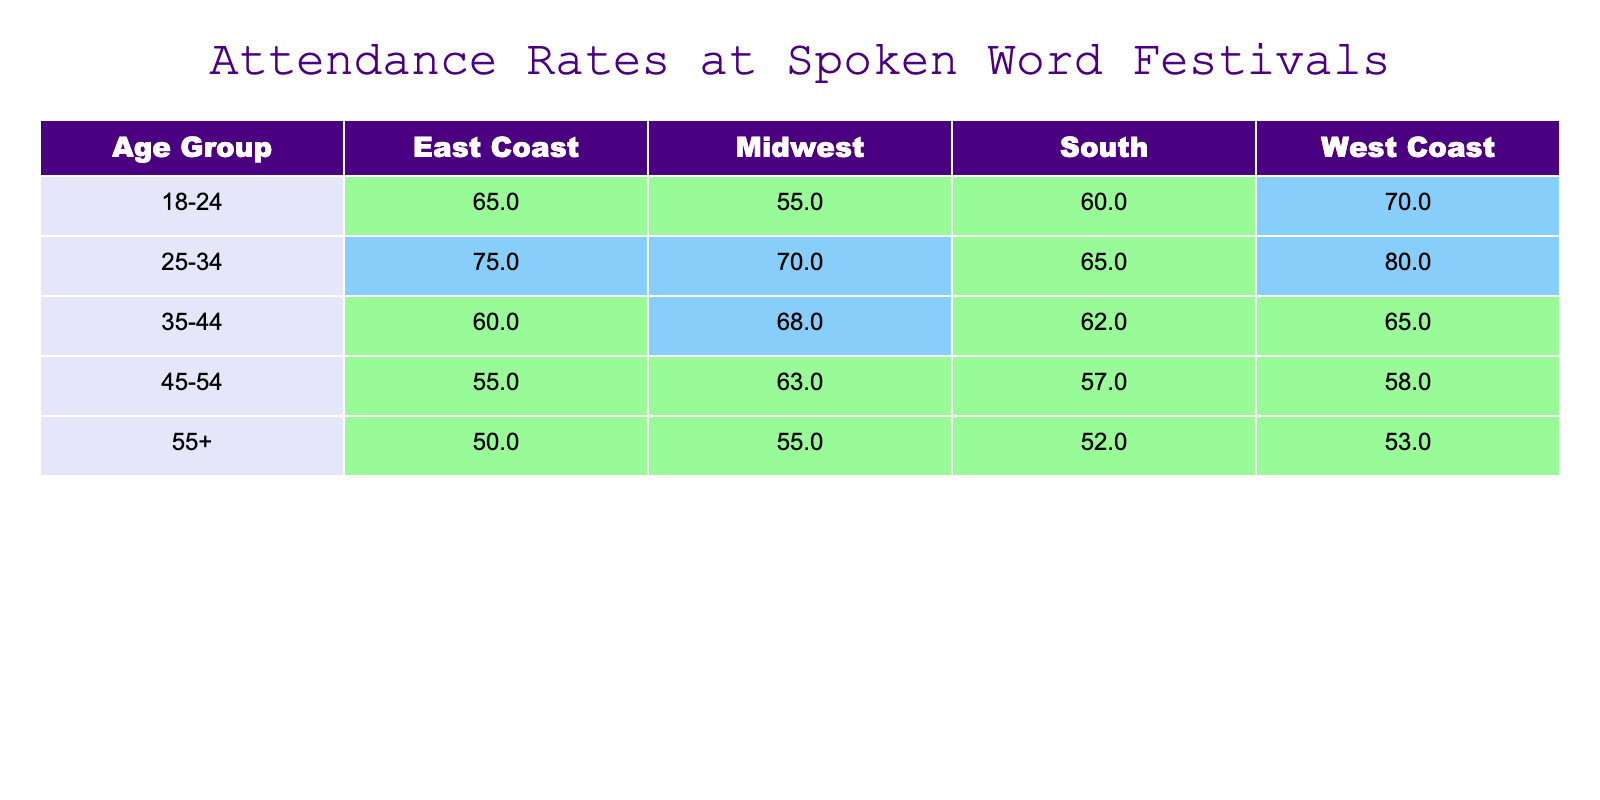What is the attendance rate for the age group 25-34 in the West Coast? The table shows that for the age group 25-34, the attendance rate in the West Coast is clearly stated as 80%.
Answer: 80 Which age group has the highest attendance rate on the East Coast? Looking at the East Coast column, the 25-34 age group has the highest attendance rate at 75%, compared to other age groups: 65% (18-24), 60% (35-44), 55% (45-54), and 50% (55+).
Answer: 25-34 What is the average attendance rate for the age group 35-44 across all regions? To calculate the average, we sum the attendance rates (60 + 65 + 68 + 62 = 255) and divide by the number of regions (4), resulting in an average attendance rate of 63.75%.
Answer: 63.75 Is the attendance rate for the 18-24 age group in the South higher than that for the 45-54 age group in the same region? The attendance rate for the 18-24 age group in the South is 60%, while the attendance for the 45-54 age group in the South is 57%. Thus, 60% is greater than 57%.
Answer: Yes Which region has the lowest attendance rate for the age group 55+? In the table, the attendance rates for the age group 55+ are: East Coast (50%), West Coast (53%), Midwest (55%), and South (52%). The East Coast has the lowest rate at 50%.
Answer: East Coast What is the difference in attendance rates between the 25-34 age group in the West Coast and the 55+ age group in the Midwest? The attendance rate for the 25-34 age group in the West Coast is 80%, while the rate for the 55+ age group in the Midwest is 55%. The difference is 80% - 55% = 25%.
Answer: 25 Are attendance rates for the West Coast generally higher than the East Coast for all age groups? Comparison of the two regions shows: 18-24 (70% vs 65%), 25-34 (80% vs 75%), 35-44 (65% vs 60%), 45-54 (58% vs 55%), 55+ (53% vs 50%). The West Coast rates are higher for the first three age groups, but lower for the last two age groups, indicating it's not consistent.
Answer: No What region has the highest average attendance rate across all age groups? To find the highest average, sum the attendance rates for each region: East Coast (65 + 75 + 60 + 55 + 50 = 305), West Coast (70 + 80 + 65 + 58 + 53 = 326), Midwest (55 + 70 + 68 + 63 + 55 = 311), South (60 + 65 + 62 + 57 + 52 = 296). The West Coast has the highest total (326) which when averaged gives the highest rate.
Answer: West Coast 